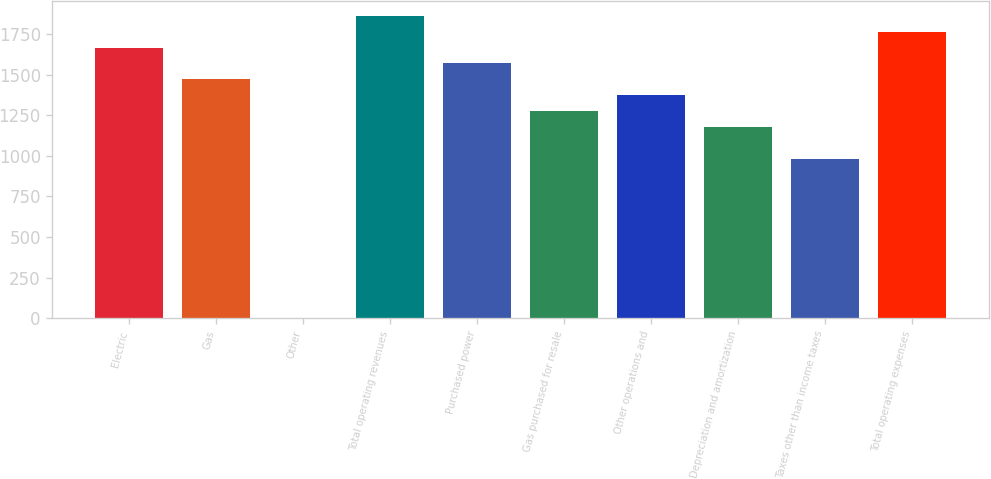<chart> <loc_0><loc_0><loc_500><loc_500><bar_chart><fcel>Electric<fcel>Gas<fcel>Other<fcel>Total operating revenues<fcel>Purchased power<fcel>Gas purchased for resale<fcel>Other operations and<fcel>Depreciation and amortization<fcel>Taxes other than income taxes<fcel>Total operating expenses<nl><fcel>1667.3<fcel>1471.5<fcel>3<fcel>1863.1<fcel>1569.4<fcel>1275.7<fcel>1373.6<fcel>1177.8<fcel>982<fcel>1765.2<nl></chart> 